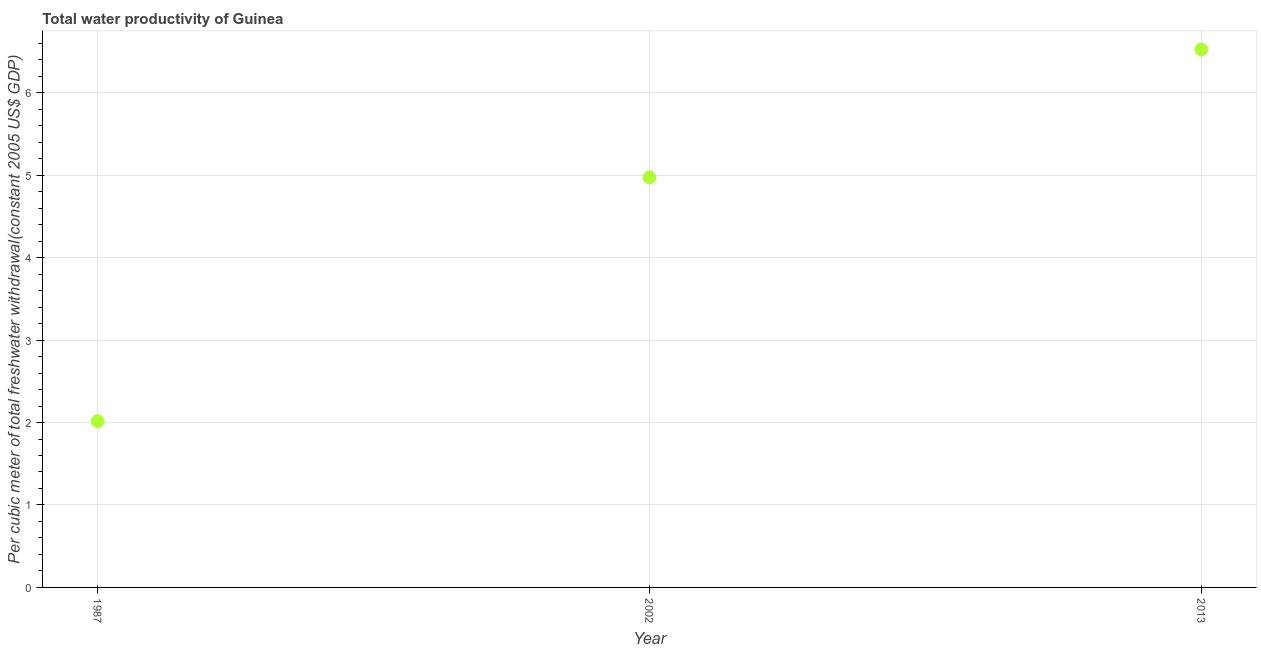What is the total water productivity in 1987?
Make the answer very short. 2.02. Across all years, what is the maximum total water productivity?
Your answer should be compact. 6.53. Across all years, what is the minimum total water productivity?
Offer a very short reply. 2.02. In which year was the total water productivity maximum?
Your answer should be very brief. 2013. In which year was the total water productivity minimum?
Your answer should be very brief. 1987. What is the sum of the total water productivity?
Offer a terse response. 13.52. What is the difference between the total water productivity in 1987 and 2002?
Your answer should be compact. -2.96. What is the average total water productivity per year?
Ensure brevity in your answer.  4.51. What is the median total water productivity?
Your answer should be very brief. 4.97. In how many years, is the total water productivity greater than 1.8 US$?
Make the answer very short. 3. What is the ratio of the total water productivity in 1987 to that in 2013?
Your answer should be very brief. 0.31. What is the difference between the highest and the second highest total water productivity?
Your answer should be compact. 1.55. What is the difference between the highest and the lowest total water productivity?
Your answer should be very brief. 4.51. Does the total water productivity monotonically increase over the years?
Your answer should be compact. Yes. Are the values on the major ticks of Y-axis written in scientific E-notation?
Provide a succinct answer. No. Does the graph contain grids?
Make the answer very short. Yes. What is the title of the graph?
Offer a very short reply. Total water productivity of Guinea. What is the label or title of the X-axis?
Offer a very short reply. Year. What is the label or title of the Y-axis?
Your answer should be compact. Per cubic meter of total freshwater withdrawal(constant 2005 US$ GDP). What is the Per cubic meter of total freshwater withdrawal(constant 2005 US$ GDP) in 1987?
Keep it short and to the point. 2.02. What is the Per cubic meter of total freshwater withdrawal(constant 2005 US$ GDP) in 2002?
Offer a very short reply. 4.97. What is the Per cubic meter of total freshwater withdrawal(constant 2005 US$ GDP) in 2013?
Provide a succinct answer. 6.53. What is the difference between the Per cubic meter of total freshwater withdrawal(constant 2005 US$ GDP) in 1987 and 2002?
Your answer should be compact. -2.96. What is the difference between the Per cubic meter of total freshwater withdrawal(constant 2005 US$ GDP) in 1987 and 2013?
Keep it short and to the point. -4.51. What is the difference between the Per cubic meter of total freshwater withdrawal(constant 2005 US$ GDP) in 2002 and 2013?
Your response must be concise. -1.55. What is the ratio of the Per cubic meter of total freshwater withdrawal(constant 2005 US$ GDP) in 1987 to that in 2002?
Offer a terse response. 0.41. What is the ratio of the Per cubic meter of total freshwater withdrawal(constant 2005 US$ GDP) in 1987 to that in 2013?
Your answer should be very brief. 0.31. What is the ratio of the Per cubic meter of total freshwater withdrawal(constant 2005 US$ GDP) in 2002 to that in 2013?
Ensure brevity in your answer.  0.76. 